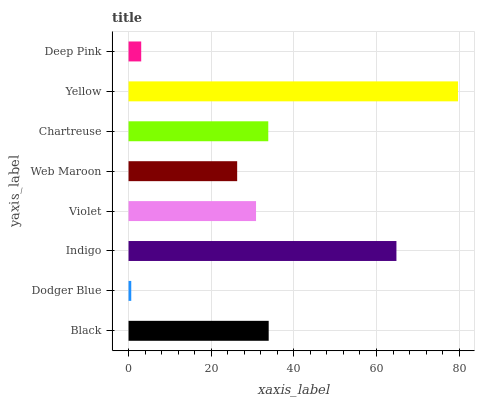Is Dodger Blue the minimum?
Answer yes or no. Yes. Is Yellow the maximum?
Answer yes or no. Yes. Is Indigo the minimum?
Answer yes or no. No. Is Indigo the maximum?
Answer yes or no. No. Is Indigo greater than Dodger Blue?
Answer yes or no. Yes. Is Dodger Blue less than Indigo?
Answer yes or no. Yes. Is Dodger Blue greater than Indigo?
Answer yes or no. No. Is Indigo less than Dodger Blue?
Answer yes or no. No. Is Chartreuse the high median?
Answer yes or no. Yes. Is Violet the low median?
Answer yes or no. Yes. Is Violet the high median?
Answer yes or no. No. Is Black the low median?
Answer yes or no. No. 